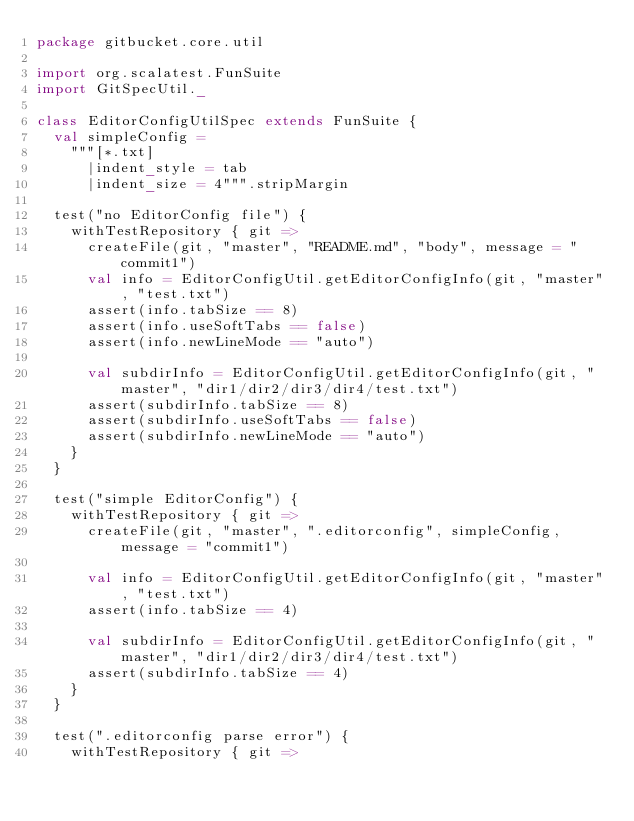Convert code to text. <code><loc_0><loc_0><loc_500><loc_500><_Scala_>package gitbucket.core.util

import org.scalatest.FunSuite
import GitSpecUtil._

class EditorConfigUtilSpec extends FunSuite {
  val simpleConfig =
    """[*.txt]
      |indent_style = tab
      |indent_size = 4""".stripMargin

  test("no EditorConfig file") {
    withTestRepository { git =>
      createFile(git, "master", "README.md", "body", message = "commit1")
      val info = EditorConfigUtil.getEditorConfigInfo(git, "master", "test.txt")
      assert(info.tabSize == 8)
      assert(info.useSoftTabs == false)
      assert(info.newLineMode == "auto")

      val subdirInfo = EditorConfigUtil.getEditorConfigInfo(git, "master", "dir1/dir2/dir3/dir4/test.txt")
      assert(subdirInfo.tabSize == 8)
      assert(subdirInfo.useSoftTabs == false)
      assert(subdirInfo.newLineMode == "auto")
    }
  }

  test("simple EditorConfig") {
    withTestRepository { git =>
      createFile(git, "master", ".editorconfig", simpleConfig, message = "commit1")

      val info = EditorConfigUtil.getEditorConfigInfo(git, "master", "test.txt")
      assert(info.tabSize == 4)

      val subdirInfo = EditorConfigUtil.getEditorConfigInfo(git, "master", "dir1/dir2/dir3/dir4/test.txt")
      assert(subdirInfo.tabSize == 4)
    }
  }

  test(".editorconfig parse error") {
    withTestRepository { git =></code> 